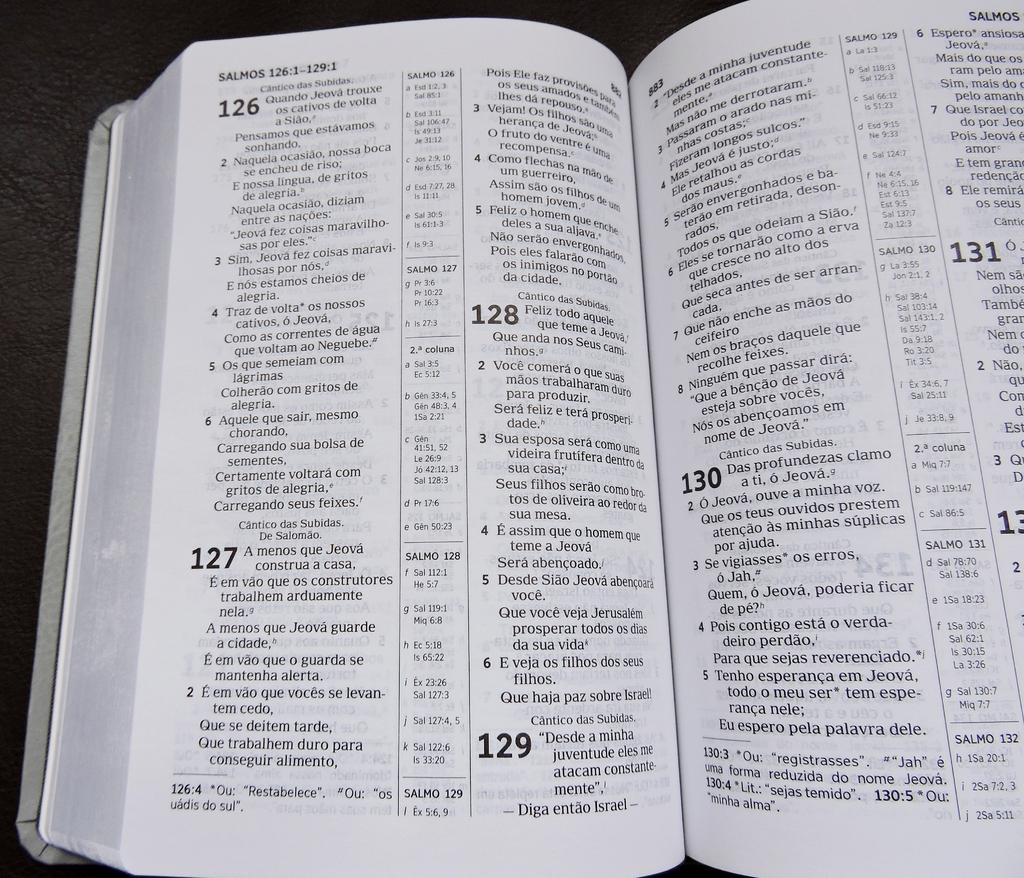<image>
Give a short and clear explanation of the subsequent image. A bible is open to chapter Salmos versus 126:1-329:1. 